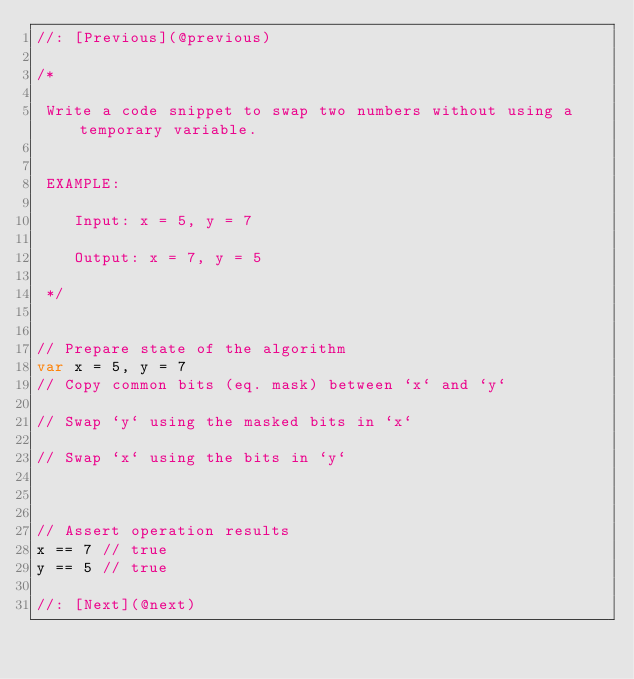Convert code to text. <code><loc_0><loc_0><loc_500><loc_500><_Swift_>//: [Previous](@previous)

/*
 
 Write a code snippet to swap two numbers without using a temporary variable.
 
 
 EXAMPLE:
 
    Input: x = 5, y = 7
 
    Output: x = 7, y = 5
 
 */


// Prepare state of the algorithm
var x = 5, y = 7
// Copy common bits (eq. mask) between `x` and `y`

// Swap `y` using the masked bits in `x`

// Swap `x` using the bits in `y`



// Assert operation results
x == 7 // true
y == 5 // true

//: [Next](@next)
</code> 